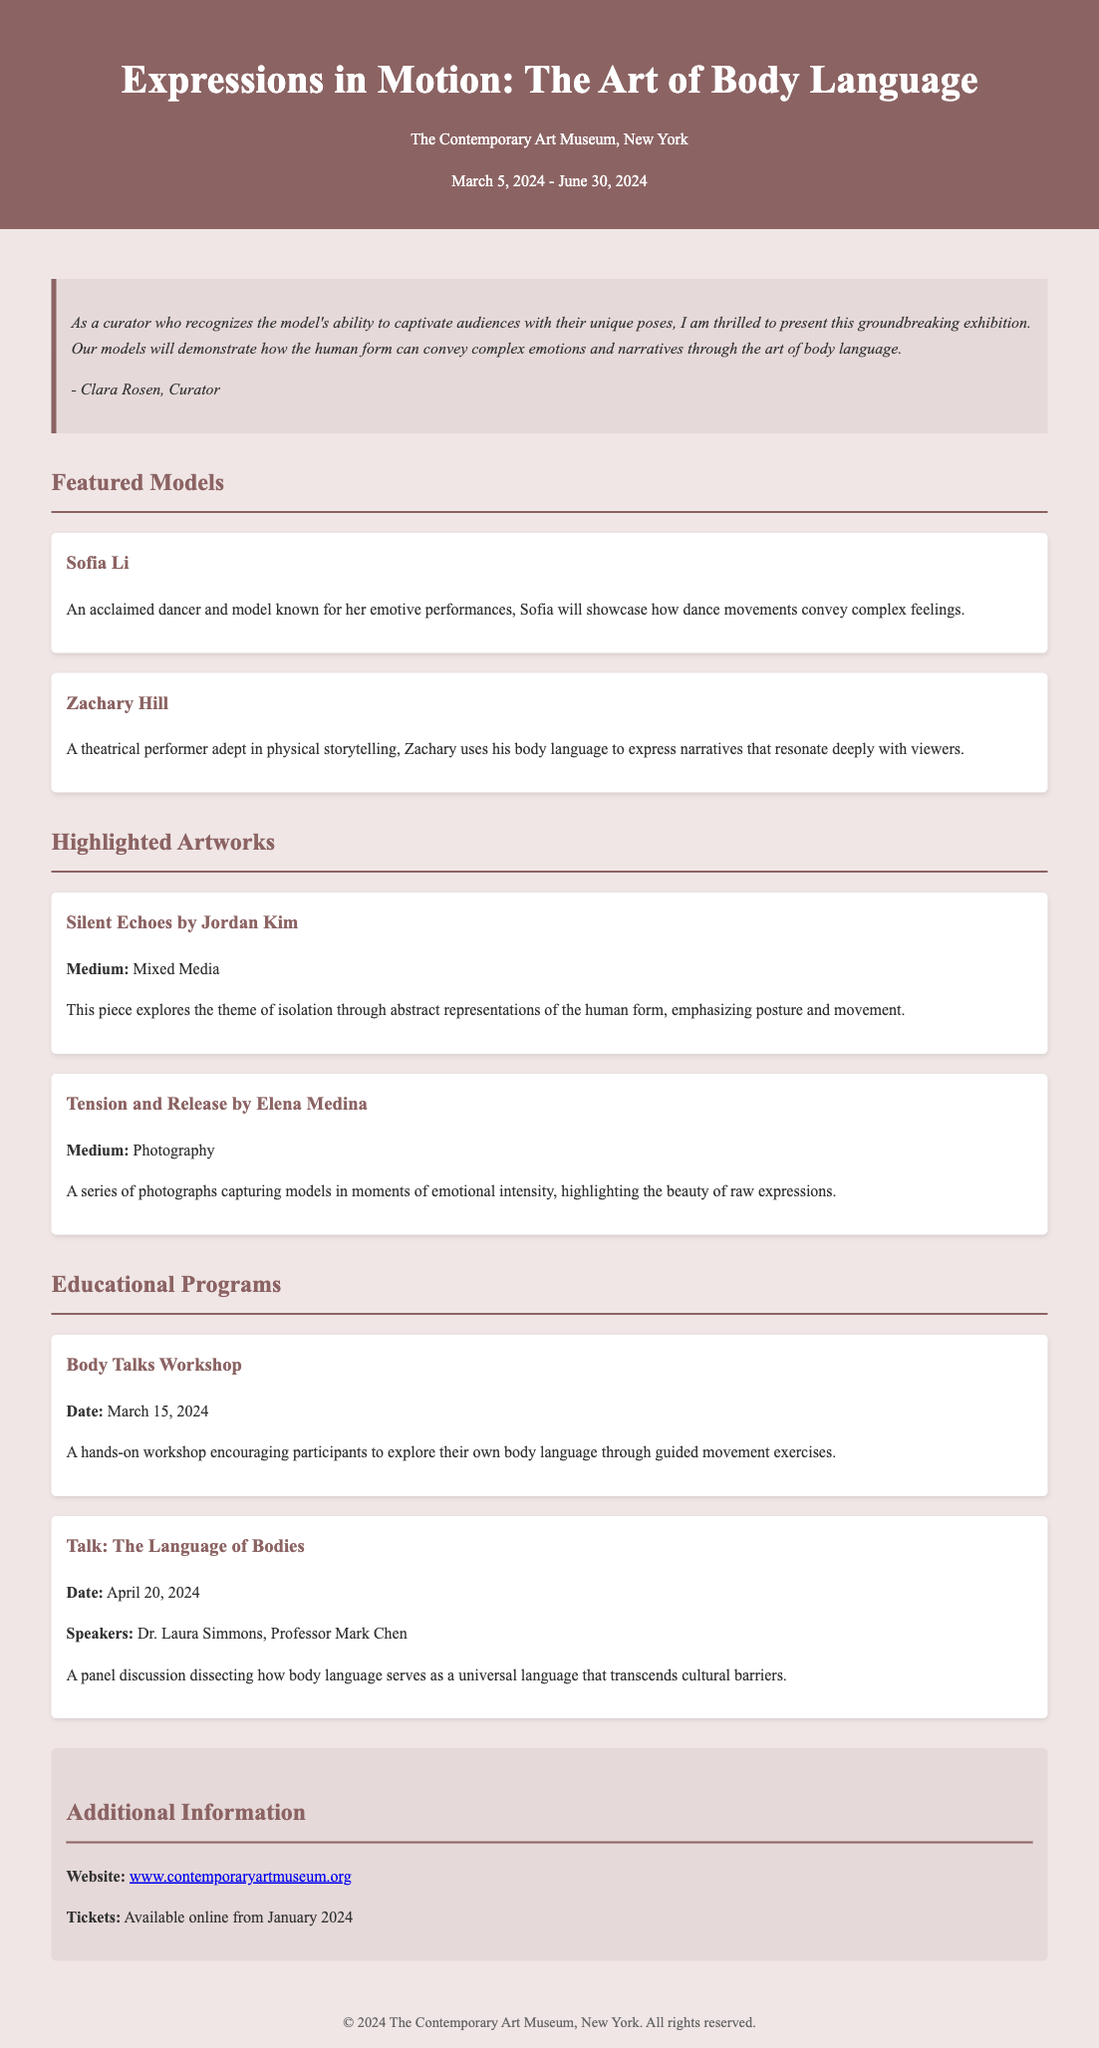what is the title of the exhibition? The title is explicitly stated at the beginning of the document.
Answer: Expressions in Motion: The Art of Body Language who is the curator of the exhibition? The curator's name is mentioned in the curator's note section.
Answer: Clara Rosen what are the dates of the exhibition? The exhibition dates are provided in the header section.
Answer: March 5, 2024 - June 30, 2024 name one of the featured models. The document includes names of featured models in a dedicated section.
Answer: Sofia Li what is the medium of *Silent Echoes*? The medium is specified in the highlighted artworks section.
Answer: Mixed Media when is the Body Talks Workshop? The date of the workshop is clearly stated under the Educational Programs section.
Answer: March 15, 2024 who are the speakers for the panel discussion? The speakers' names are mentioned within the Educational Programs section.
Answer: Dr. Laura Simmons, Professor Mark Chen what theme does *Silent Echoes* explore? The theme is described in the context of the artwork details.
Answer: Isolation how can tickets be purchased? The document specifies when and where tickets will be available.
Answer: Online from January 2024 